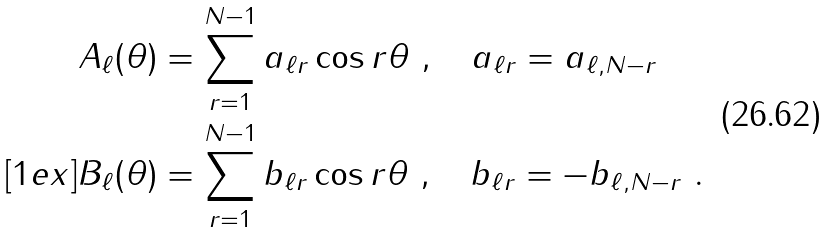<formula> <loc_0><loc_0><loc_500><loc_500>A _ { \ell } ( \theta ) & = \sum _ { r = 1 } ^ { N - 1 } a _ { \ell r } \cos r \theta \ , \quad a _ { \ell r } = a _ { \ell , N - r } \\ [ 1 e x ] B _ { \ell } ( \theta ) & = \sum _ { r = 1 } ^ { N - 1 } b _ { \ell r } \cos r \theta \ , \quad b _ { \ell r } = - b _ { \ell , N - r } \ .</formula> 